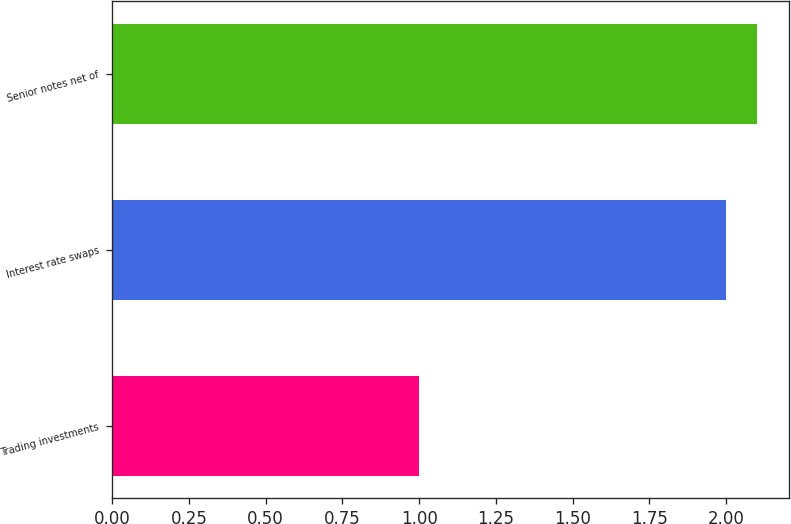Convert chart to OTSL. <chart><loc_0><loc_0><loc_500><loc_500><bar_chart><fcel>Trading investments<fcel>Interest rate swaps<fcel>Senior notes net of<nl><fcel>1<fcel>2<fcel>2.1<nl></chart> 